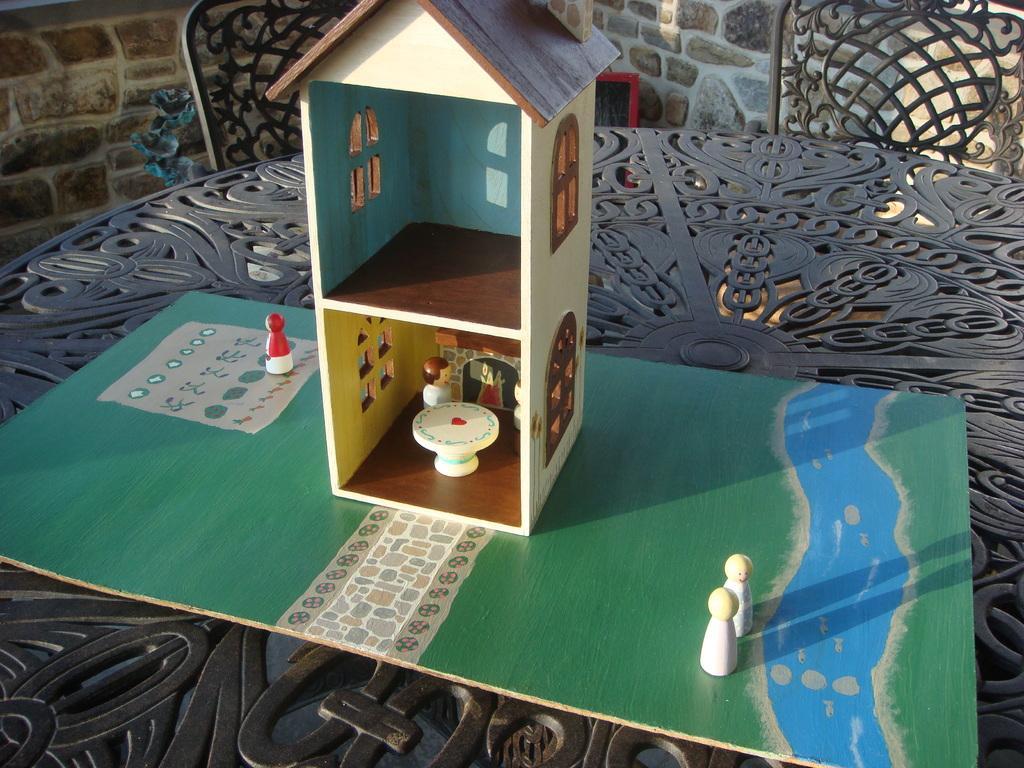Can you describe this image briefly? In this picture we can see toy house on the table. We can see chairs. On the background we can see wall. 